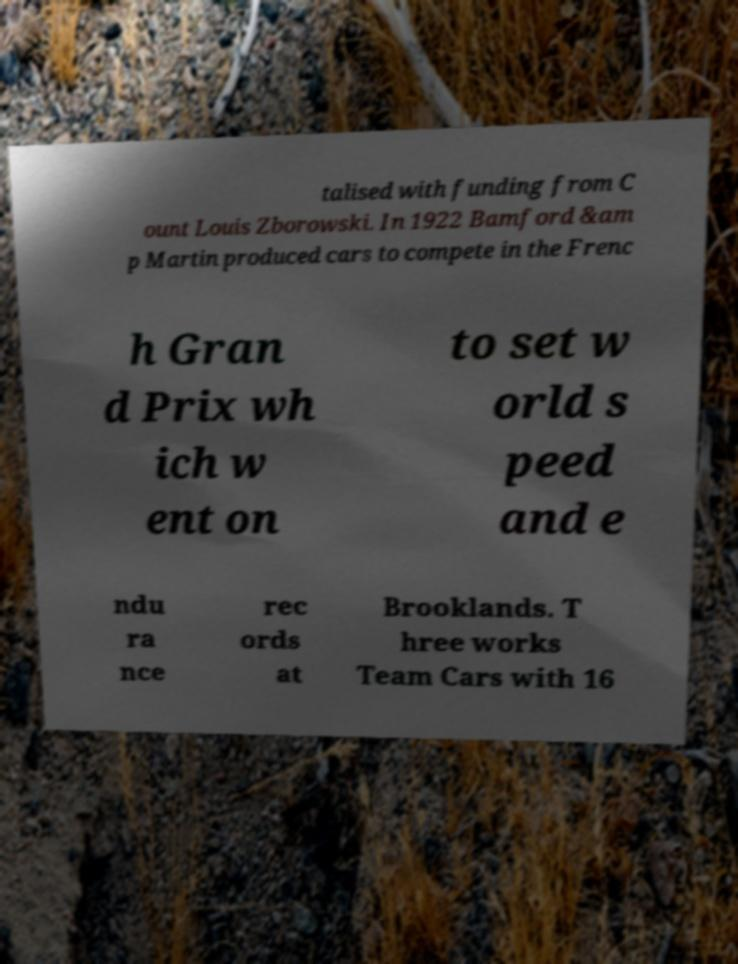Can you read and provide the text displayed in the image?This photo seems to have some interesting text. Can you extract and type it out for me? talised with funding from C ount Louis Zborowski. In 1922 Bamford &am p Martin produced cars to compete in the Frenc h Gran d Prix wh ich w ent on to set w orld s peed and e ndu ra nce rec ords at Brooklands. T hree works Team Cars with 16 